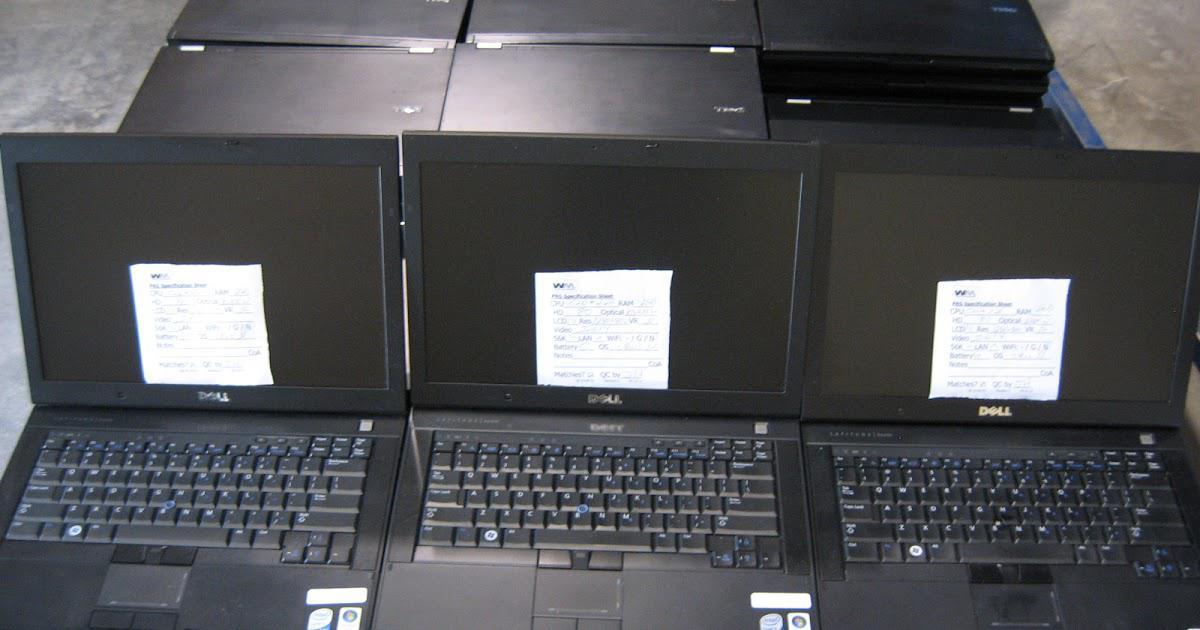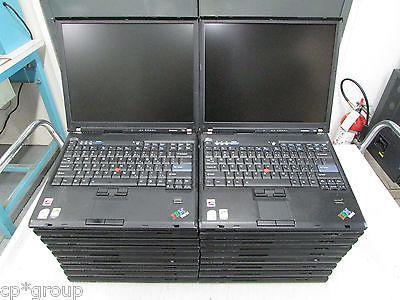The first image is the image on the left, the second image is the image on the right. Assess this claim about the two images: "The left image shows laptops in horizontal rows of three and includes rows of open laptops and rows of closed laptops.". Correct or not? Answer yes or no. Yes. The first image is the image on the left, the second image is the image on the right. Given the left and right images, does the statement "There are exactly five open laptops." hold true? Answer yes or no. Yes. 